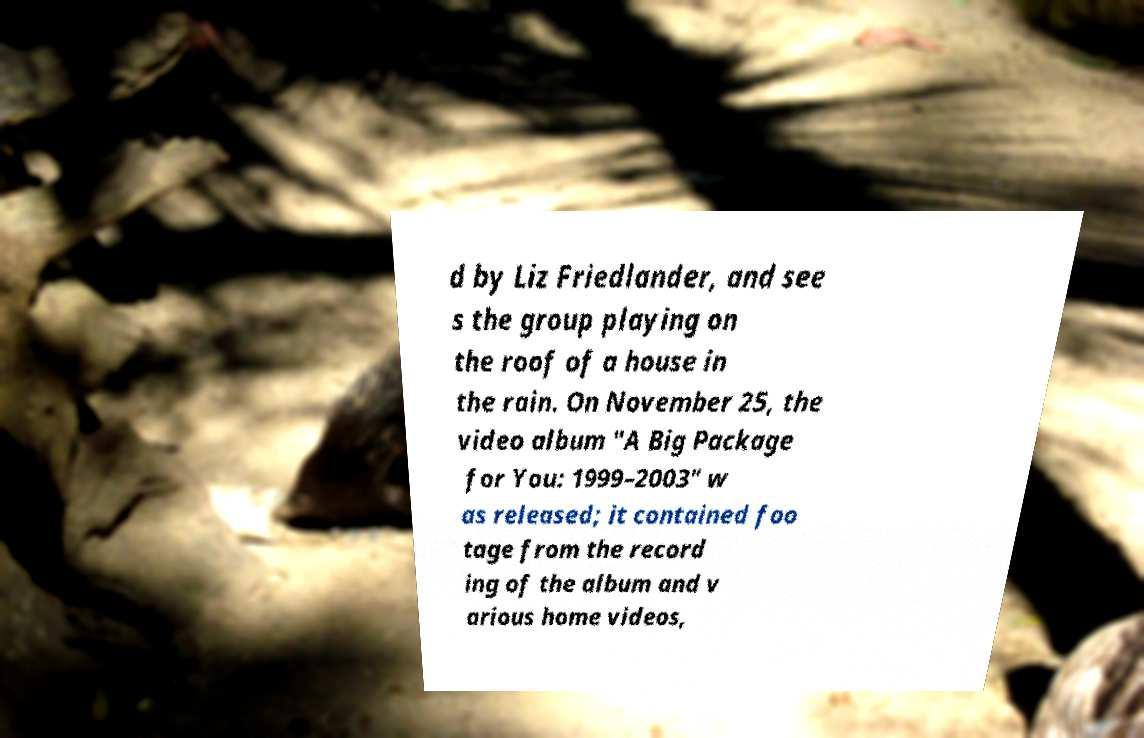There's text embedded in this image that I need extracted. Can you transcribe it verbatim? d by Liz Friedlander, and see s the group playing on the roof of a house in the rain. On November 25, the video album "A Big Package for You: 1999–2003" w as released; it contained foo tage from the record ing of the album and v arious home videos, 